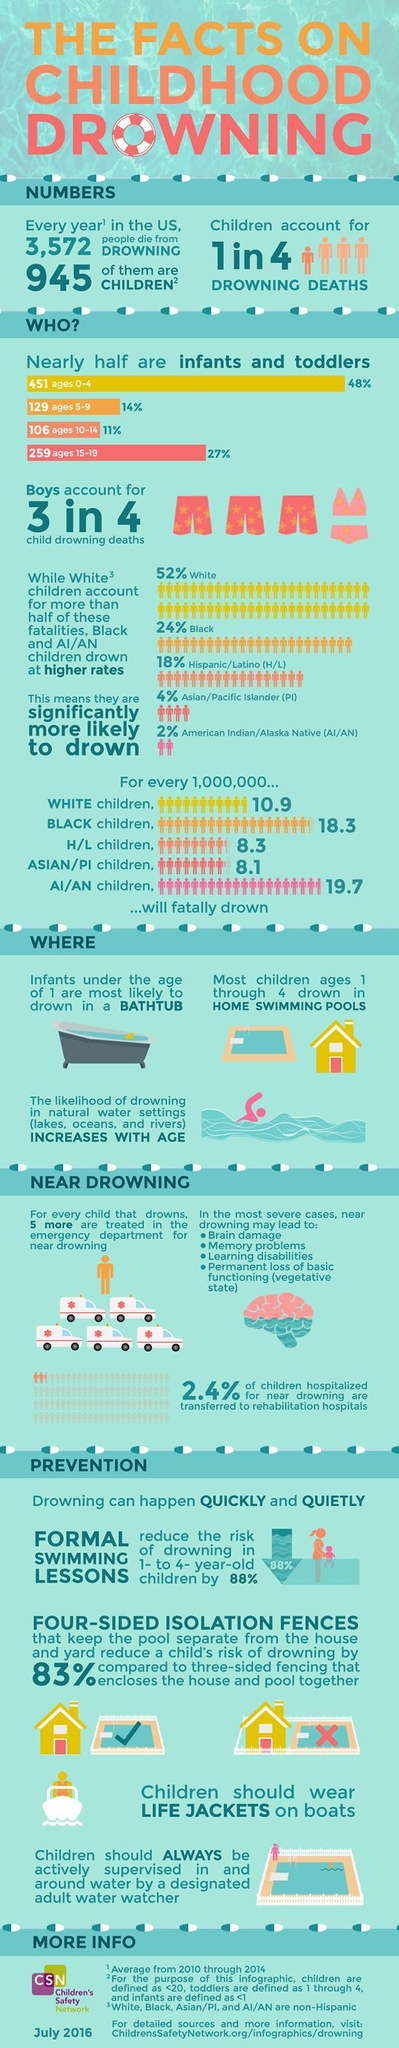What percentage of drowning deaths are children
Answer the question with a short phrase. 25 which age group in children has second highest drowning death rates 15-19 what can reduce the risk of drowning by 88% Formal swimming lessons how many sided fencing for pools is safer four-sided What % of drowning deaths are boys 75 How many deaths in the age group 0-9 580 What PPE is suggested for children on boats Life jackets What is the total % of fatality in Black and Asian/Pacific Islander 28 